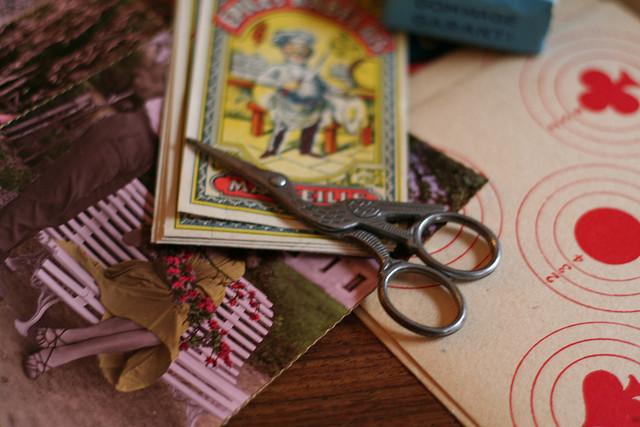Does this stationary belong to a man or woman?
Answer briefly. Woman. What are the scissors being used for?
Answer briefly. Cutting. How many heart shapes are visible?
Concise answer only. 0. Is there a camera?
Give a very brief answer. No. How many scissors are on the board?
Quick response, please. 1. Who is sitting on the park bench?
Write a very short answer. Woman. Why is there a key to a car in the photo?
Give a very brief answer. No. How many books are there?
Answer briefly. 1. What color is the scissor handle?
Give a very brief answer. Silver. 